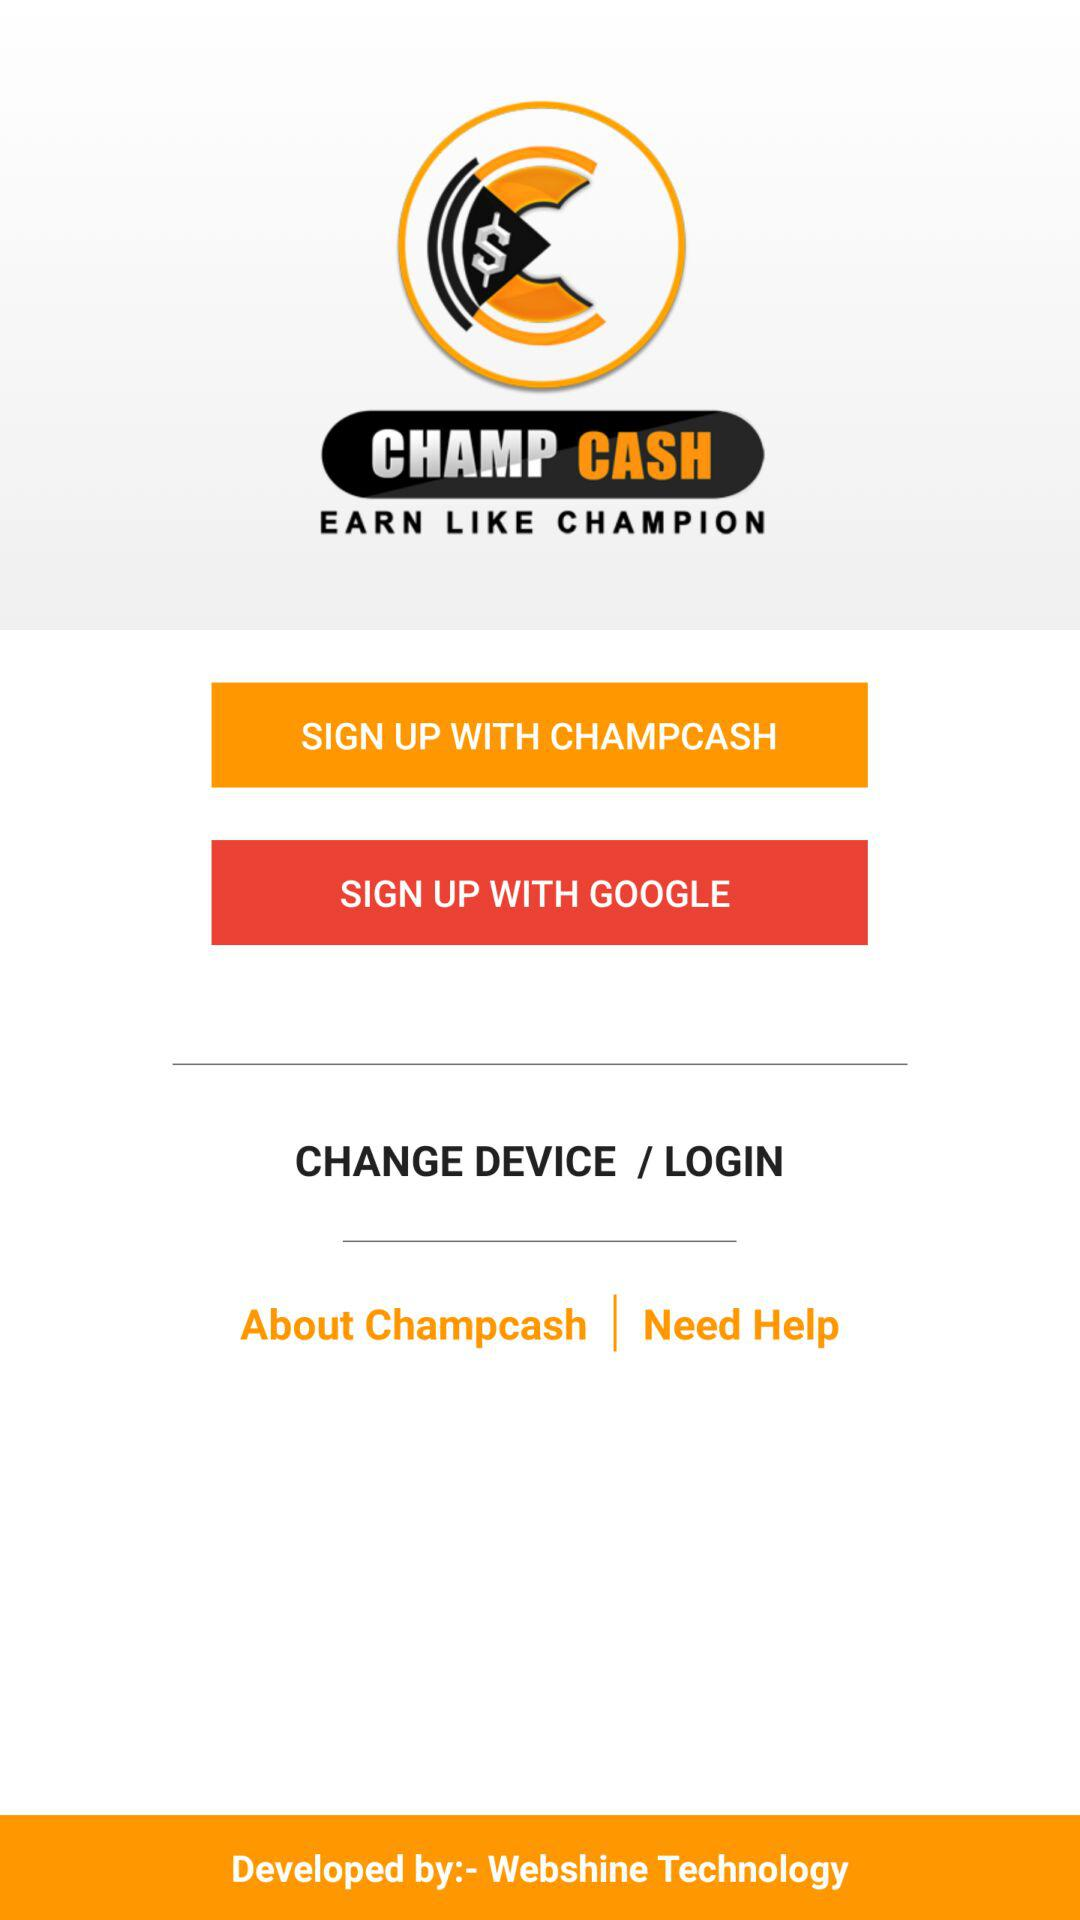What is the app name? The app name is "CHAMP CASH". 